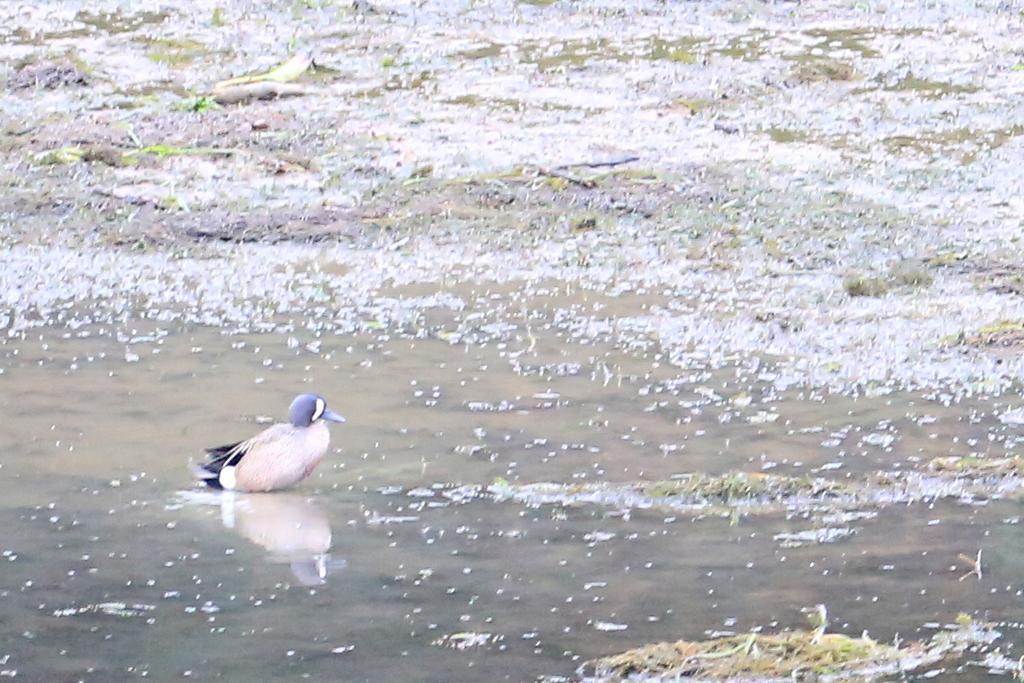How would you summarize this image in a sentence or two? In this image I can see the bird in the water. I can see the grass and the water. 